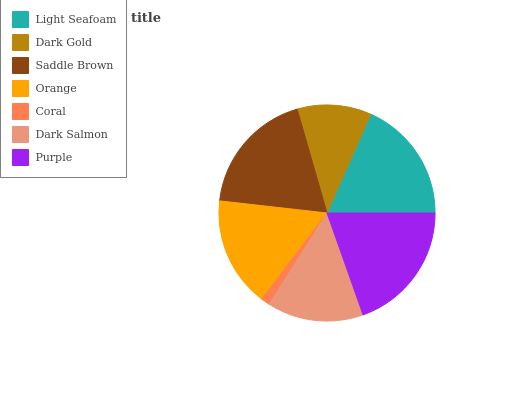Is Coral the minimum?
Answer yes or no. Yes. Is Purple the maximum?
Answer yes or no. Yes. Is Dark Gold the minimum?
Answer yes or no. No. Is Dark Gold the maximum?
Answer yes or no. No. Is Light Seafoam greater than Dark Gold?
Answer yes or no. Yes. Is Dark Gold less than Light Seafoam?
Answer yes or no. Yes. Is Dark Gold greater than Light Seafoam?
Answer yes or no. No. Is Light Seafoam less than Dark Gold?
Answer yes or no. No. Is Orange the high median?
Answer yes or no. Yes. Is Orange the low median?
Answer yes or no. Yes. Is Light Seafoam the high median?
Answer yes or no. No. Is Dark Gold the low median?
Answer yes or no. No. 